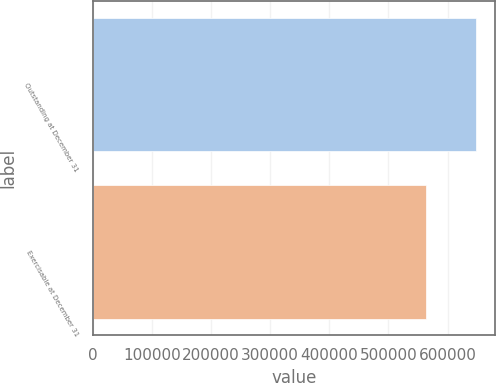Convert chart. <chart><loc_0><loc_0><loc_500><loc_500><bar_chart><fcel>Outstanding at December 31<fcel>Exercisable at December 31<nl><fcel>648034<fcel>562684<nl></chart> 